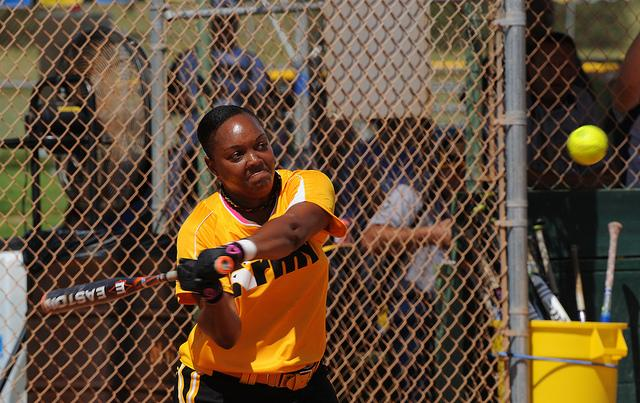Judging by the batters expression how hard is she swinging the bat? hard 